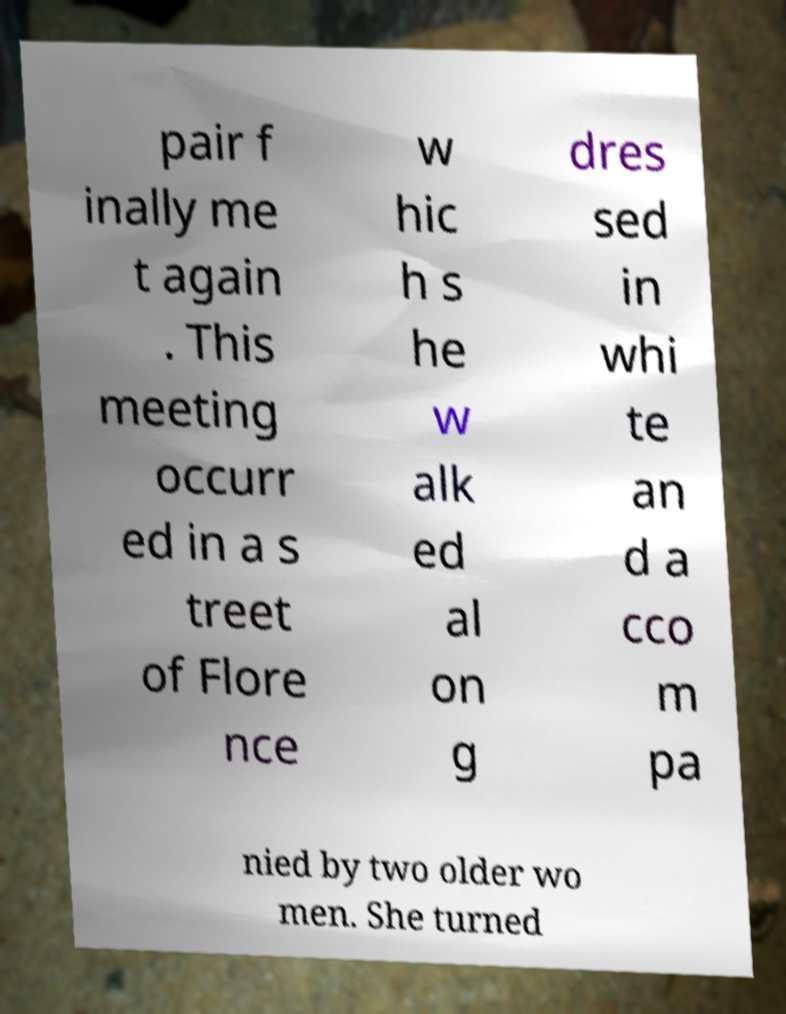Could you assist in decoding the text presented in this image and type it out clearly? pair f inally me t again . This meeting occurr ed in a s treet of Flore nce w hic h s he w alk ed al on g dres sed in whi te an d a cco m pa nied by two older wo men. She turned 